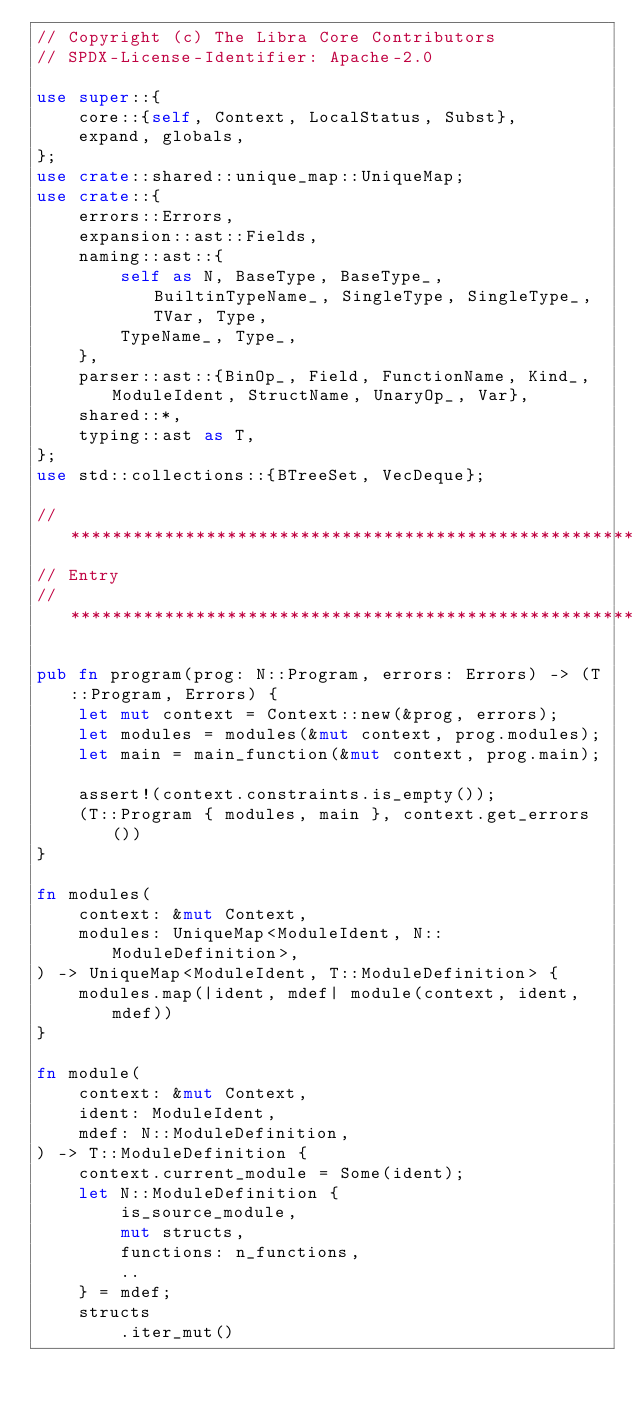<code> <loc_0><loc_0><loc_500><loc_500><_Rust_>// Copyright (c) The Libra Core Contributors
// SPDX-License-Identifier: Apache-2.0

use super::{
    core::{self, Context, LocalStatus, Subst},
    expand, globals,
};
use crate::shared::unique_map::UniqueMap;
use crate::{
    errors::Errors,
    expansion::ast::Fields,
    naming::ast::{
        self as N, BaseType, BaseType_, BuiltinTypeName_, SingleType, SingleType_, TVar, Type,
        TypeName_, Type_,
    },
    parser::ast::{BinOp_, Field, FunctionName, Kind_, ModuleIdent, StructName, UnaryOp_, Var},
    shared::*,
    typing::ast as T,
};
use std::collections::{BTreeSet, VecDeque};

//**************************************************************************************************
// Entry
//**************************************************************************************************

pub fn program(prog: N::Program, errors: Errors) -> (T::Program, Errors) {
    let mut context = Context::new(&prog, errors);
    let modules = modules(&mut context, prog.modules);
    let main = main_function(&mut context, prog.main);

    assert!(context.constraints.is_empty());
    (T::Program { modules, main }, context.get_errors())
}

fn modules(
    context: &mut Context,
    modules: UniqueMap<ModuleIdent, N::ModuleDefinition>,
) -> UniqueMap<ModuleIdent, T::ModuleDefinition> {
    modules.map(|ident, mdef| module(context, ident, mdef))
}

fn module(
    context: &mut Context,
    ident: ModuleIdent,
    mdef: N::ModuleDefinition,
) -> T::ModuleDefinition {
    context.current_module = Some(ident);
    let N::ModuleDefinition {
        is_source_module,
        mut structs,
        functions: n_functions,
        ..
    } = mdef;
    structs
        .iter_mut()</code> 